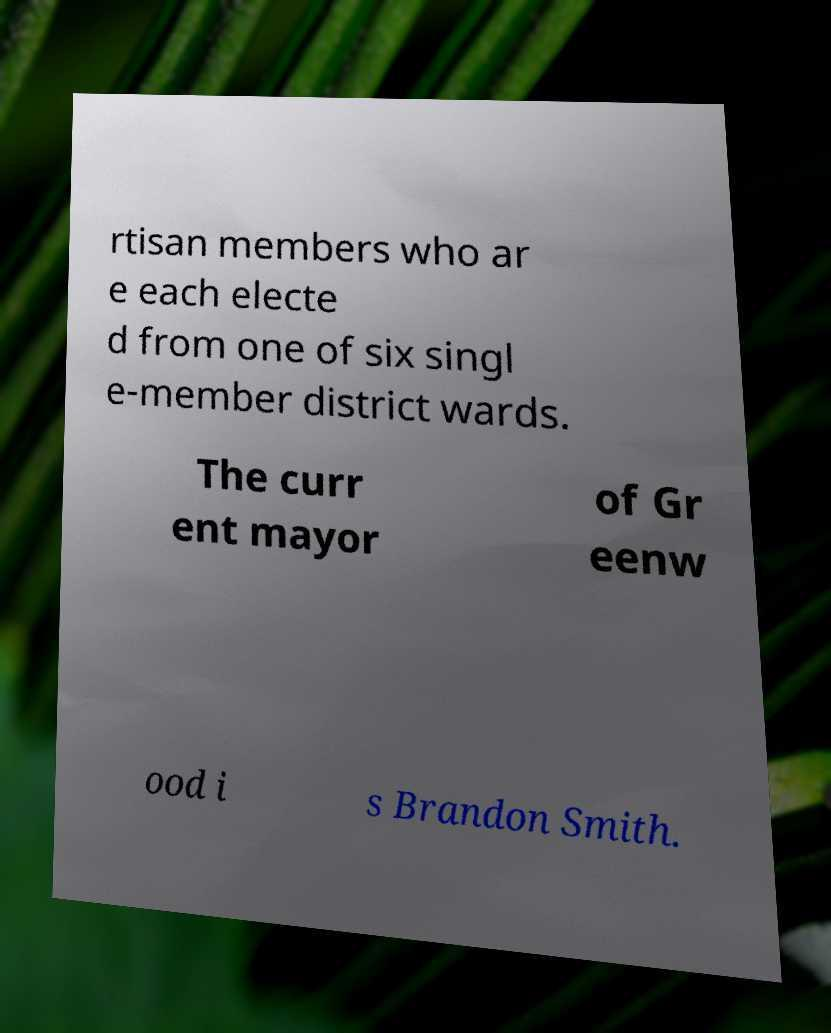Please read and relay the text visible in this image. What does it say? rtisan members who ar e each electe d from one of six singl e-member district wards. The curr ent mayor of Gr eenw ood i s Brandon Smith. 